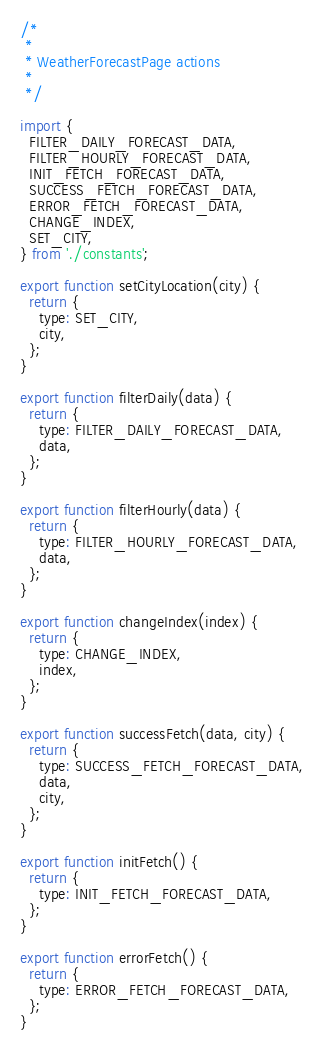Convert code to text. <code><loc_0><loc_0><loc_500><loc_500><_JavaScript_>/*
 *
 * WeatherForecastPage actions
 *
 */

import {
  FILTER_DAILY_FORECAST_DATA,
  FILTER_HOURLY_FORECAST_DATA,
  INIT_FETCH_FORECAST_DATA,
  SUCCESS_FETCH_FORECAST_DATA,
  ERROR_FETCH_FORECAST_DATA,
  CHANGE_INDEX,
  SET_CITY,
} from './constants';

export function setCityLocation(city) {
  return {
    type: SET_CITY,
    city,
  };
}

export function filterDaily(data) {
  return {
    type: FILTER_DAILY_FORECAST_DATA,
    data,
  };
}

export function filterHourly(data) {
  return {
    type: FILTER_HOURLY_FORECAST_DATA,
    data,
  };
}

export function changeIndex(index) {
  return {
    type: CHANGE_INDEX,
    index,
  };
}

export function successFetch(data, city) {
  return {
    type: SUCCESS_FETCH_FORECAST_DATA,
    data,
    city,
  };
}

export function initFetch() {
  return {
    type: INIT_FETCH_FORECAST_DATA,
  };
}

export function errorFetch() {
  return {
    type: ERROR_FETCH_FORECAST_DATA,
  };
}
</code> 